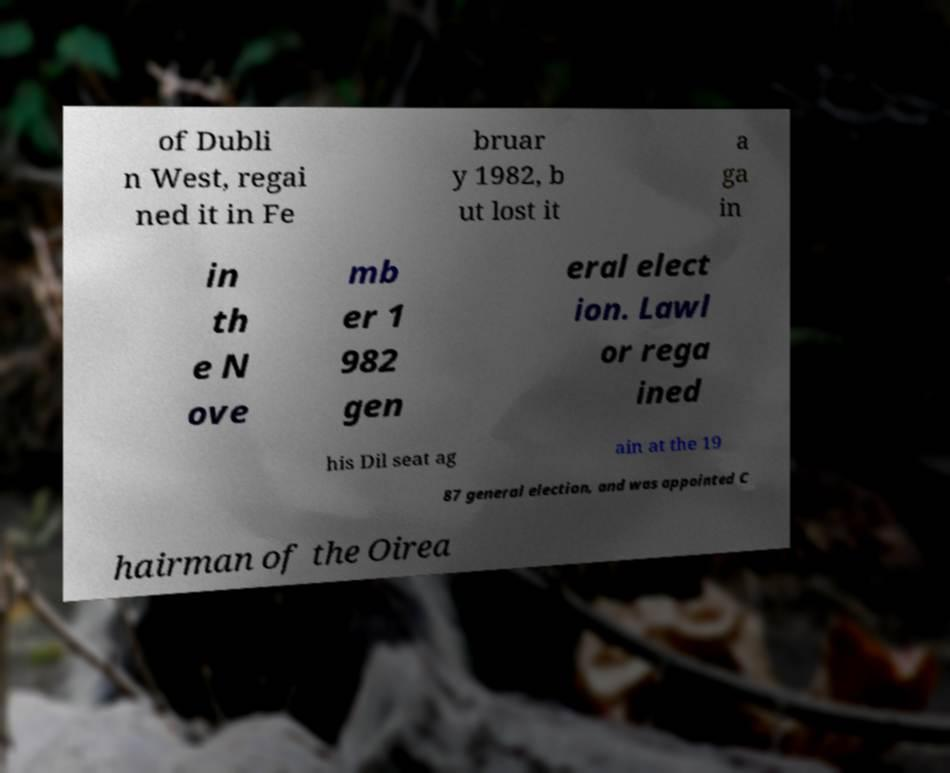What messages or text are displayed in this image? I need them in a readable, typed format. of Dubli n West, regai ned it in Fe bruar y 1982, b ut lost it a ga in in th e N ove mb er 1 982 gen eral elect ion. Lawl or rega ined his Dil seat ag ain at the 19 87 general election, and was appointed C hairman of the Oirea 